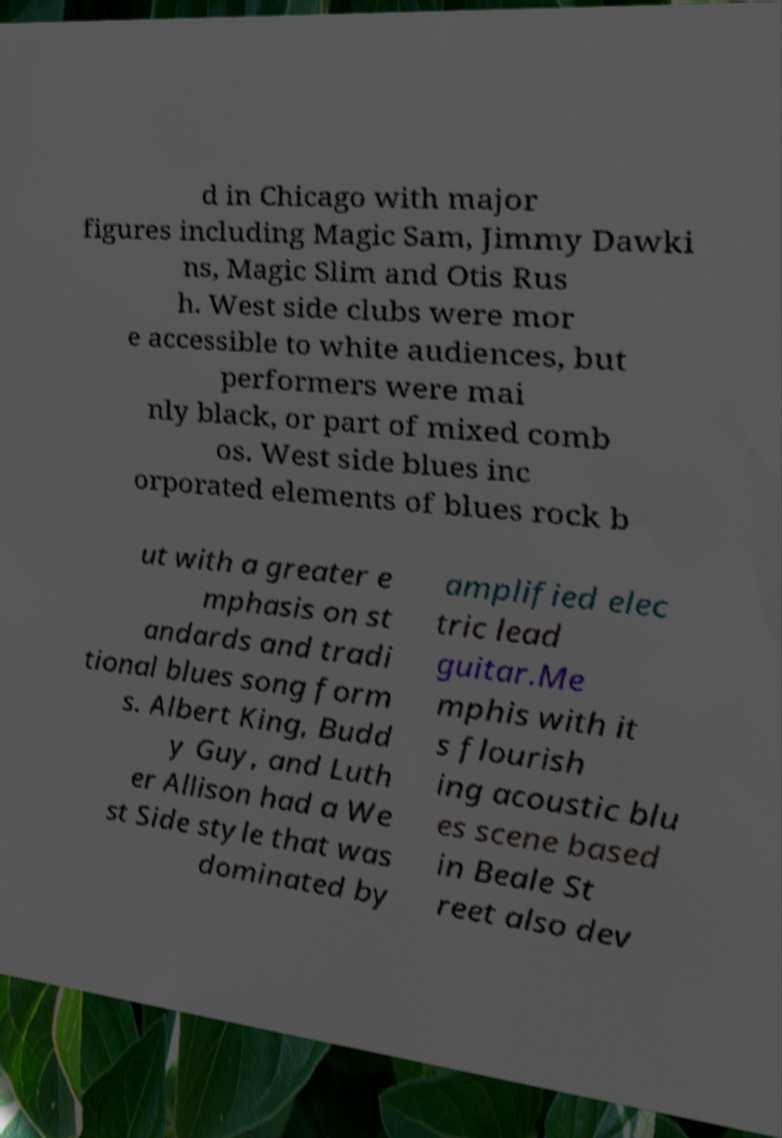Could you assist in decoding the text presented in this image and type it out clearly? d in Chicago with major figures including Magic Sam, Jimmy Dawki ns, Magic Slim and Otis Rus h. West side clubs were mor e accessible to white audiences, but performers were mai nly black, or part of mixed comb os. West side blues inc orporated elements of blues rock b ut with a greater e mphasis on st andards and tradi tional blues song form s. Albert King, Budd y Guy, and Luth er Allison had a We st Side style that was dominated by amplified elec tric lead guitar.Me mphis with it s flourish ing acoustic blu es scene based in Beale St reet also dev 